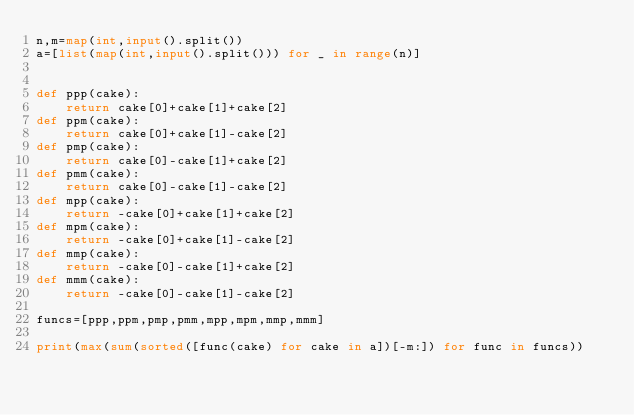<code> <loc_0><loc_0><loc_500><loc_500><_Python_>n,m=map(int,input().split())
a=[list(map(int,input().split())) for _ in range(n)]


def ppp(cake):
    return cake[0]+cake[1]+cake[2]
def ppm(cake):
    return cake[0]+cake[1]-cake[2]
def pmp(cake):
    return cake[0]-cake[1]+cake[2]
def pmm(cake):
    return cake[0]-cake[1]-cake[2]
def mpp(cake):
    return -cake[0]+cake[1]+cake[2]
def mpm(cake):
    return -cake[0]+cake[1]-cake[2]
def mmp(cake):
    return -cake[0]-cake[1]+cake[2]
def mmm(cake):
    return -cake[0]-cake[1]-cake[2]

funcs=[ppp,ppm,pmp,pmm,mpp,mpm,mmp,mmm]

print(max(sum(sorted([func(cake) for cake in a])[-m:]) for func in funcs))</code> 